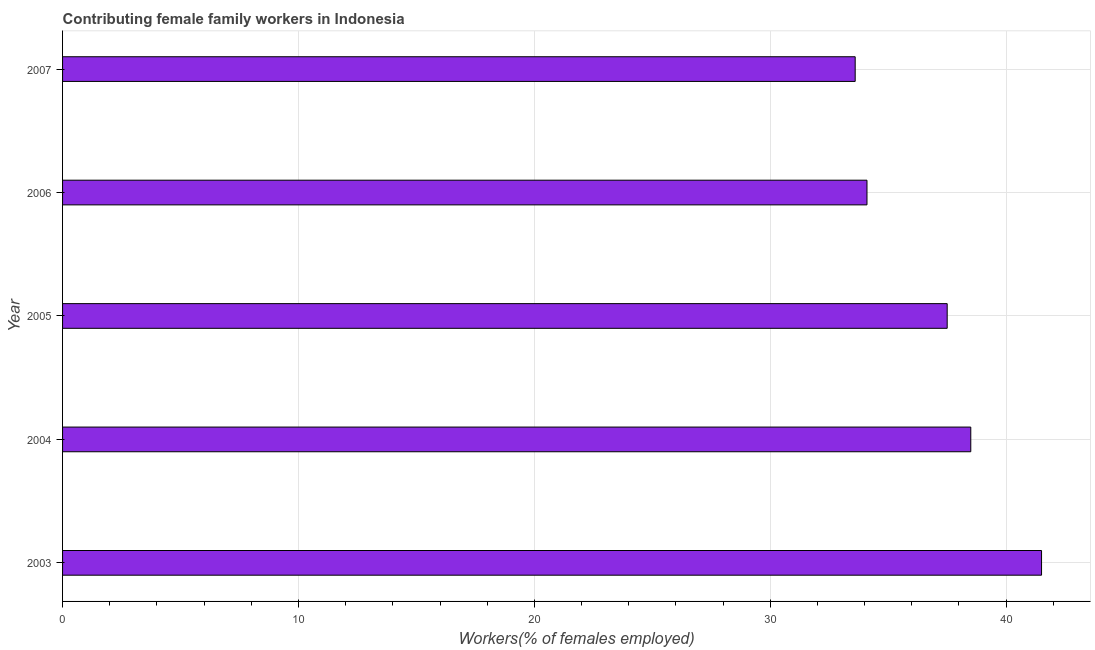Does the graph contain grids?
Ensure brevity in your answer.  Yes. What is the title of the graph?
Provide a short and direct response. Contributing female family workers in Indonesia. What is the label or title of the X-axis?
Offer a very short reply. Workers(% of females employed). What is the contributing female family workers in 2003?
Ensure brevity in your answer.  41.5. Across all years, what is the maximum contributing female family workers?
Offer a very short reply. 41.5. Across all years, what is the minimum contributing female family workers?
Give a very brief answer. 33.6. In which year was the contributing female family workers minimum?
Provide a succinct answer. 2007. What is the sum of the contributing female family workers?
Provide a succinct answer. 185.2. What is the difference between the contributing female family workers in 2005 and 2007?
Make the answer very short. 3.9. What is the average contributing female family workers per year?
Provide a short and direct response. 37.04. What is the median contributing female family workers?
Offer a terse response. 37.5. In how many years, is the contributing female family workers greater than 6 %?
Give a very brief answer. 5. What is the ratio of the contributing female family workers in 2005 to that in 2007?
Your answer should be very brief. 1.12. What is the difference between the highest and the second highest contributing female family workers?
Your answer should be compact. 3. What is the difference between the highest and the lowest contributing female family workers?
Keep it short and to the point. 7.9. How many bars are there?
Offer a very short reply. 5. Are all the bars in the graph horizontal?
Provide a short and direct response. Yes. How many years are there in the graph?
Offer a terse response. 5. What is the difference between two consecutive major ticks on the X-axis?
Provide a succinct answer. 10. Are the values on the major ticks of X-axis written in scientific E-notation?
Ensure brevity in your answer.  No. What is the Workers(% of females employed) of 2003?
Your answer should be compact. 41.5. What is the Workers(% of females employed) in 2004?
Offer a very short reply. 38.5. What is the Workers(% of females employed) in 2005?
Ensure brevity in your answer.  37.5. What is the Workers(% of females employed) of 2006?
Your answer should be compact. 34.1. What is the Workers(% of females employed) of 2007?
Make the answer very short. 33.6. What is the difference between the Workers(% of females employed) in 2003 and 2004?
Keep it short and to the point. 3. What is the difference between the Workers(% of females employed) in 2003 and 2007?
Your answer should be compact. 7.9. What is the difference between the Workers(% of females employed) in 2004 and 2005?
Give a very brief answer. 1. What is the difference between the Workers(% of females employed) in 2004 and 2006?
Offer a terse response. 4.4. What is the difference between the Workers(% of females employed) in 2004 and 2007?
Your answer should be very brief. 4.9. What is the difference between the Workers(% of females employed) in 2006 and 2007?
Keep it short and to the point. 0.5. What is the ratio of the Workers(% of females employed) in 2003 to that in 2004?
Your answer should be very brief. 1.08. What is the ratio of the Workers(% of females employed) in 2003 to that in 2005?
Your answer should be very brief. 1.11. What is the ratio of the Workers(% of females employed) in 2003 to that in 2006?
Give a very brief answer. 1.22. What is the ratio of the Workers(% of females employed) in 2003 to that in 2007?
Keep it short and to the point. 1.24. What is the ratio of the Workers(% of females employed) in 2004 to that in 2005?
Provide a short and direct response. 1.03. What is the ratio of the Workers(% of females employed) in 2004 to that in 2006?
Ensure brevity in your answer.  1.13. What is the ratio of the Workers(% of females employed) in 2004 to that in 2007?
Give a very brief answer. 1.15. What is the ratio of the Workers(% of females employed) in 2005 to that in 2007?
Ensure brevity in your answer.  1.12. What is the ratio of the Workers(% of females employed) in 2006 to that in 2007?
Provide a short and direct response. 1.01. 